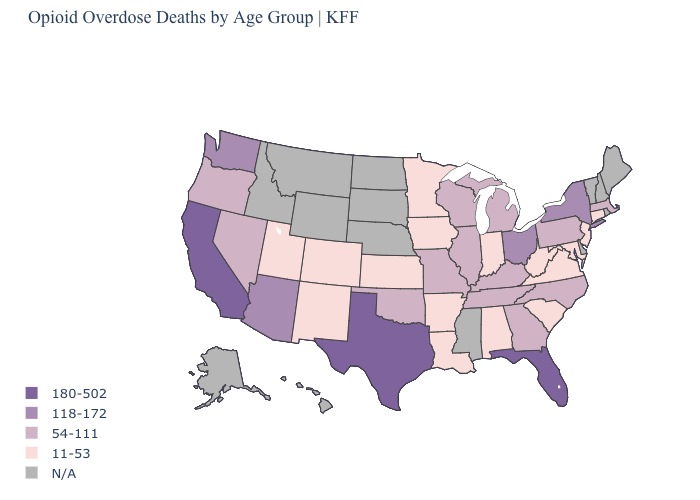Does New York have the highest value in the USA?
Quick response, please. No. What is the value of Massachusetts?
Write a very short answer. 54-111. Is the legend a continuous bar?
Write a very short answer. No. Which states have the highest value in the USA?
Answer briefly. California, Florida, Texas. Name the states that have a value in the range 118-172?
Concise answer only. Arizona, New York, Ohio, Washington. Name the states that have a value in the range 118-172?
Keep it brief. Arizona, New York, Ohio, Washington. Name the states that have a value in the range 180-502?
Answer briefly. California, Florida, Texas. What is the highest value in the USA?
Concise answer only. 180-502. What is the value of Connecticut?
Answer briefly. 11-53. Name the states that have a value in the range 180-502?
Answer briefly. California, Florida, Texas. Name the states that have a value in the range 11-53?
Write a very short answer. Alabama, Arkansas, Colorado, Connecticut, Indiana, Iowa, Kansas, Louisiana, Maryland, Minnesota, New Jersey, New Mexico, South Carolina, Utah, Virginia, West Virginia. Does Ohio have the highest value in the MidWest?
Write a very short answer. Yes. Which states hav the highest value in the Northeast?
Be succinct. New York. Which states have the lowest value in the South?
Answer briefly. Alabama, Arkansas, Louisiana, Maryland, South Carolina, Virginia, West Virginia. What is the value of Delaware?
Answer briefly. N/A. 